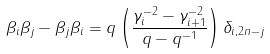Convert formula to latex. <formula><loc_0><loc_0><loc_500><loc_500>\beta _ { i } \beta _ { j } - \beta _ { j } \beta _ { i } = q \left ( \frac { \gamma _ { i } ^ { - 2 } - \gamma _ { i + 1 } ^ { - 2 } } { q - q ^ { - 1 } } \right ) \delta _ { i , 2 n - j }</formula> 